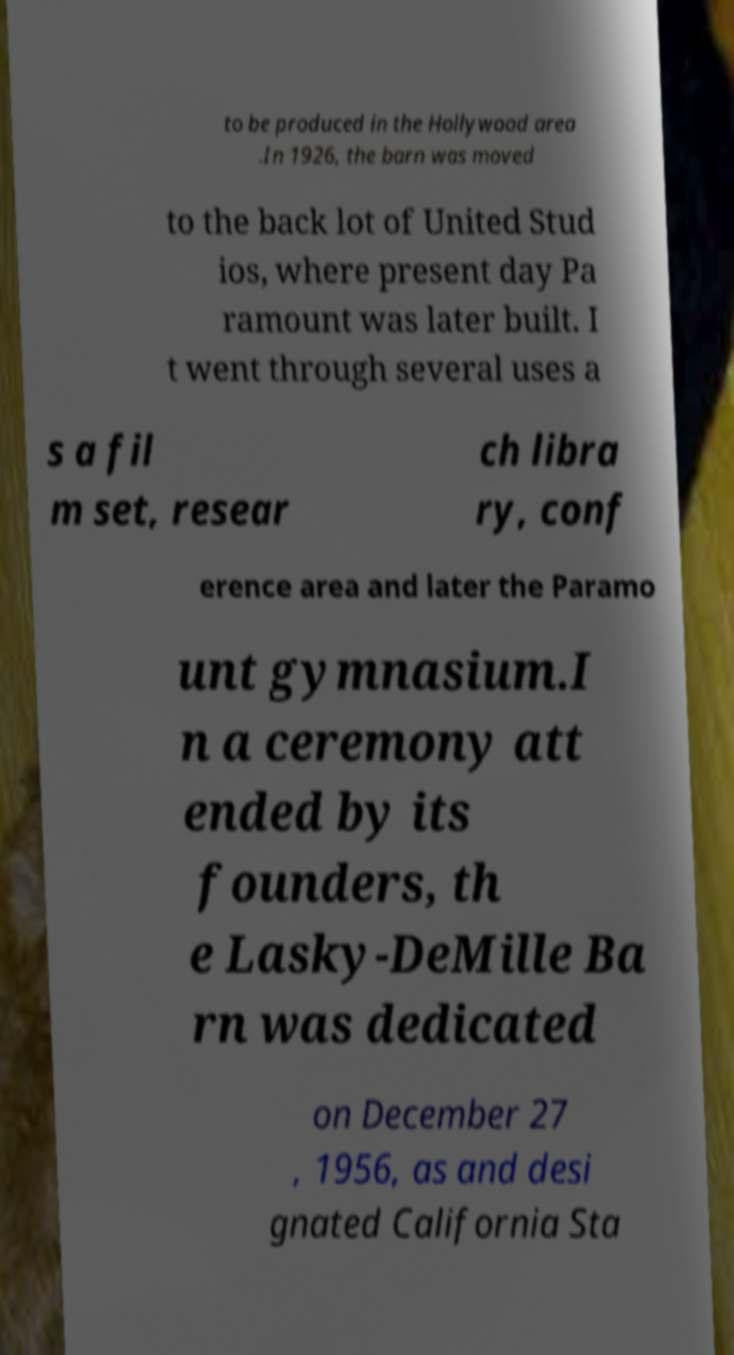There's text embedded in this image that I need extracted. Can you transcribe it verbatim? to be produced in the Hollywood area .In 1926, the barn was moved to the back lot of United Stud ios, where present day Pa ramount was later built. I t went through several uses a s a fil m set, resear ch libra ry, conf erence area and later the Paramo unt gymnasium.I n a ceremony att ended by its founders, th e Lasky-DeMille Ba rn was dedicated on December 27 , 1956, as and desi gnated California Sta 